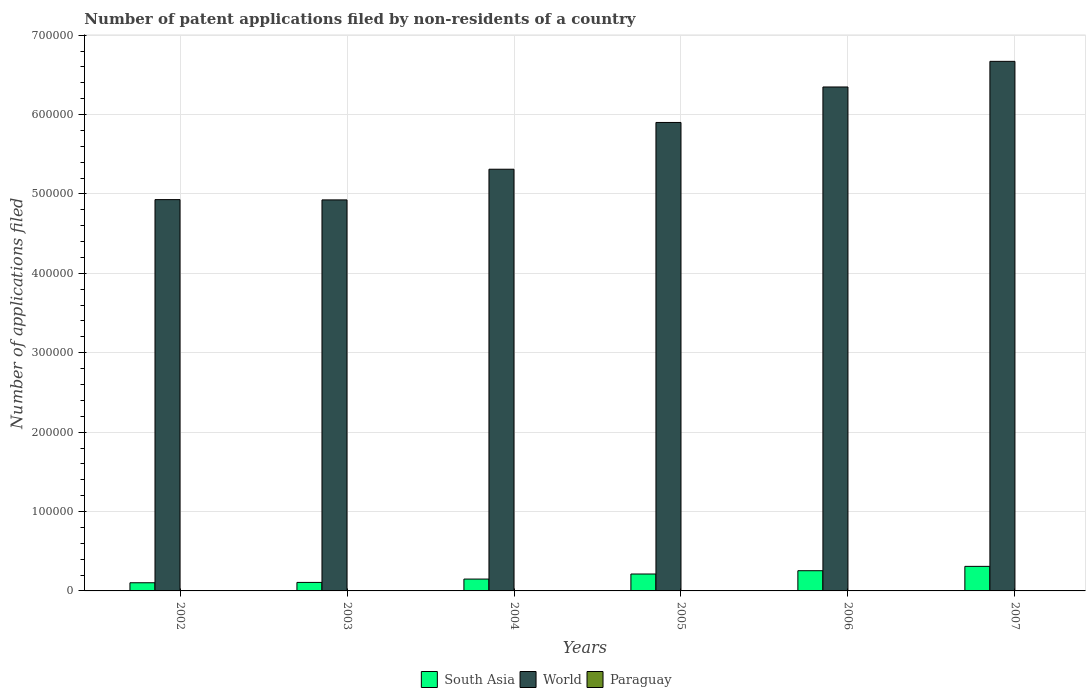How many different coloured bars are there?
Keep it short and to the point. 3. Are the number of bars per tick equal to the number of legend labels?
Offer a very short reply. Yes. How many bars are there on the 3rd tick from the right?
Offer a terse response. 3. What is the number of applications filed in Paraguay in 2002?
Offer a terse response. 171. Across all years, what is the maximum number of applications filed in Paraguay?
Ensure brevity in your answer.  364. Across all years, what is the minimum number of applications filed in Paraguay?
Make the answer very short. 171. What is the total number of applications filed in Paraguay in the graph?
Give a very brief answer. 1431. What is the difference between the number of applications filed in World in 2002 and that in 2005?
Provide a short and direct response. -9.72e+04. What is the difference between the number of applications filed in World in 2007 and the number of applications filed in Paraguay in 2005?
Provide a succinct answer. 6.67e+05. What is the average number of applications filed in South Asia per year?
Your answer should be compact. 1.89e+04. In the year 2005, what is the difference between the number of applications filed in Paraguay and number of applications filed in World?
Make the answer very short. -5.90e+05. In how many years, is the number of applications filed in Paraguay greater than 620000?
Your answer should be compact. 0. What is the ratio of the number of applications filed in South Asia in 2005 to that in 2007?
Keep it short and to the point. 0.69. What is the difference between the highest and the lowest number of applications filed in South Asia?
Offer a very short reply. 2.06e+04. In how many years, is the number of applications filed in World greater than the average number of applications filed in World taken over all years?
Provide a short and direct response. 3. What does the 3rd bar from the left in 2007 represents?
Provide a short and direct response. Paraguay. How many bars are there?
Your answer should be very brief. 18. How many legend labels are there?
Your response must be concise. 3. What is the title of the graph?
Provide a short and direct response. Number of patent applications filed by non-residents of a country. What is the label or title of the Y-axis?
Make the answer very short. Number of applications filed. What is the Number of applications filed of South Asia in 2002?
Your answer should be very brief. 1.03e+04. What is the Number of applications filed of World in 2002?
Provide a short and direct response. 4.93e+05. What is the Number of applications filed in Paraguay in 2002?
Provide a short and direct response. 171. What is the Number of applications filed of South Asia in 2003?
Provide a succinct answer. 1.07e+04. What is the Number of applications filed in World in 2003?
Offer a terse response. 4.93e+05. What is the Number of applications filed of Paraguay in 2003?
Your response must be concise. 173. What is the Number of applications filed of South Asia in 2004?
Your response must be concise. 1.49e+04. What is the Number of applications filed in World in 2004?
Your answer should be compact. 5.31e+05. What is the Number of applications filed of Paraguay in 2004?
Make the answer very short. 187. What is the Number of applications filed in South Asia in 2005?
Make the answer very short. 2.13e+04. What is the Number of applications filed in World in 2005?
Ensure brevity in your answer.  5.90e+05. What is the Number of applications filed in Paraguay in 2005?
Your response must be concise. 241. What is the Number of applications filed in South Asia in 2006?
Make the answer very short. 2.54e+04. What is the Number of applications filed in World in 2006?
Your response must be concise. 6.35e+05. What is the Number of applications filed in Paraguay in 2006?
Provide a succinct answer. 364. What is the Number of applications filed of South Asia in 2007?
Your response must be concise. 3.09e+04. What is the Number of applications filed of World in 2007?
Ensure brevity in your answer.  6.67e+05. What is the Number of applications filed of Paraguay in 2007?
Offer a very short reply. 295. Across all years, what is the maximum Number of applications filed in South Asia?
Offer a very short reply. 3.09e+04. Across all years, what is the maximum Number of applications filed of World?
Ensure brevity in your answer.  6.67e+05. Across all years, what is the maximum Number of applications filed of Paraguay?
Keep it short and to the point. 364. Across all years, what is the minimum Number of applications filed in South Asia?
Ensure brevity in your answer.  1.03e+04. Across all years, what is the minimum Number of applications filed in World?
Offer a terse response. 4.93e+05. Across all years, what is the minimum Number of applications filed in Paraguay?
Your answer should be very brief. 171. What is the total Number of applications filed of South Asia in the graph?
Your answer should be very brief. 1.14e+05. What is the total Number of applications filed in World in the graph?
Provide a short and direct response. 3.41e+06. What is the total Number of applications filed of Paraguay in the graph?
Make the answer very short. 1431. What is the difference between the Number of applications filed of South Asia in 2002 and that in 2003?
Ensure brevity in your answer.  -430. What is the difference between the Number of applications filed of World in 2002 and that in 2003?
Give a very brief answer. 348. What is the difference between the Number of applications filed of Paraguay in 2002 and that in 2003?
Provide a succinct answer. -2. What is the difference between the Number of applications filed of South Asia in 2002 and that in 2004?
Offer a very short reply. -4646. What is the difference between the Number of applications filed in World in 2002 and that in 2004?
Offer a very short reply. -3.83e+04. What is the difference between the Number of applications filed of South Asia in 2002 and that in 2005?
Your answer should be compact. -1.10e+04. What is the difference between the Number of applications filed in World in 2002 and that in 2005?
Your answer should be very brief. -9.72e+04. What is the difference between the Number of applications filed in Paraguay in 2002 and that in 2005?
Ensure brevity in your answer.  -70. What is the difference between the Number of applications filed of South Asia in 2002 and that in 2006?
Offer a very short reply. -1.52e+04. What is the difference between the Number of applications filed in World in 2002 and that in 2006?
Ensure brevity in your answer.  -1.42e+05. What is the difference between the Number of applications filed in Paraguay in 2002 and that in 2006?
Your answer should be very brief. -193. What is the difference between the Number of applications filed in South Asia in 2002 and that in 2007?
Offer a very short reply. -2.06e+04. What is the difference between the Number of applications filed of World in 2002 and that in 2007?
Your response must be concise. -1.74e+05. What is the difference between the Number of applications filed of Paraguay in 2002 and that in 2007?
Your response must be concise. -124. What is the difference between the Number of applications filed in South Asia in 2003 and that in 2004?
Your answer should be very brief. -4216. What is the difference between the Number of applications filed in World in 2003 and that in 2004?
Ensure brevity in your answer.  -3.86e+04. What is the difference between the Number of applications filed in South Asia in 2003 and that in 2005?
Your answer should be compact. -1.06e+04. What is the difference between the Number of applications filed in World in 2003 and that in 2005?
Your answer should be very brief. -9.75e+04. What is the difference between the Number of applications filed of Paraguay in 2003 and that in 2005?
Your answer should be very brief. -68. What is the difference between the Number of applications filed in South Asia in 2003 and that in 2006?
Keep it short and to the point. -1.47e+04. What is the difference between the Number of applications filed in World in 2003 and that in 2006?
Ensure brevity in your answer.  -1.42e+05. What is the difference between the Number of applications filed in Paraguay in 2003 and that in 2006?
Give a very brief answer. -191. What is the difference between the Number of applications filed in South Asia in 2003 and that in 2007?
Give a very brief answer. -2.02e+04. What is the difference between the Number of applications filed of World in 2003 and that in 2007?
Offer a terse response. -1.75e+05. What is the difference between the Number of applications filed in Paraguay in 2003 and that in 2007?
Provide a succinct answer. -122. What is the difference between the Number of applications filed in South Asia in 2004 and that in 2005?
Offer a very short reply. -6384. What is the difference between the Number of applications filed of World in 2004 and that in 2005?
Your response must be concise. -5.89e+04. What is the difference between the Number of applications filed in Paraguay in 2004 and that in 2005?
Provide a succinct answer. -54. What is the difference between the Number of applications filed of South Asia in 2004 and that in 2006?
Your answer should be very brief. -1.05e+04. What is the difference between the Number of applications filed in World in 2004 and that in 2006?
Your response must be concise. -1.04e+05. What is the difference between the Number of applications filed of Paraguay in 2004 and that in 2006?
Offer a terse response. -177. What is the difference between the Number of applications filed of South Asia in 2004 and that in 2007?
Provide a short and direct response. -1.60e+04. What is the difference between the Number of applications filed in World in 2004 and that in 2007?
Your answer should be very brief. -1.36e+05. What is the difference between the Number of applications filed in Paraguay in 2004 and that in 2007?
Your answer should be compact. -108. What is the difference between the Number of applications filed in South Asia in 2005 and that in 2006?
Your response must be concise. -4140. What is the difference between the Number of applications filed of World in 2005 and that in 2006?
Keep it short and to the point. -4.47e+04. What is the difference between the Number of applications filed of Paraguay in 2005 and that in 2006?
Offer a very short reply. -123. What is the difference between the Number of applications filed in South Asia in 2005 and that in 2007?
Provide a succinct answer. -9613. What is the difference between the Number of applications filed in World in 2005 and that in 2007?
Provide a succinct answer. -7.70e+04. What is the difference between the Number of applications filed in Paraguay in 2005 and that in 2007?
Your answer should be very brief. -54. What is the difference between the Number of applications filed of South Asia in 2006 and that in 2007?
Make the answer very short. -5473. What is the difference between the Number of applications filed of World in 2006 and that in 2007?
Your answer should be very brief. -3.23e+04. What is the difference between the Number of applications filed of Paraguay in 2006 and that in 2007?
Your response must be concise. 69. What is the difference between the Number of applications filed of South Asia in 2002 and the Number of applications filed of World in 2003?
Your answer should be compact. -4.82e+05. What is the difference between the Number of applications filed of South Asia in 2002 and the Number of applications filed of Paraguay in 2003?
Provide a succinct answer. 1.01e+04. What is the difference between the Number of applications filed in World in 2002 and the Number of applications filed in Paraguay in 2003?
Your response must be concise. 4.93e+05. What is the difference between the Number of applications filed in South Asia in 2002 and the Number of applications filed in World in 2004?
Your answer should be compact. -5.21e+05. What is the difference between the Number of applications filed of South Asia in 2002 and the Number of applications filed of Paraguay in 2004?
Offer a terse response. 1.01e+04. What is the difference between the Number of applications filed of World in 2002 and the Number of applications filed of Paraguay in 2004?
Give a very brief answer. 4.93e+05. What is the difference between the Number of applications filed in South Asia in 2002 and the Number of applications filed in World in 2005?
Offer a terse response. -5.80e+05. What is the difference between the Number of applications filed in South Asia in 2002 and the Number of applications filed in Paraguay in 2005?
Your response must be concise. 1.00e+04. What is the difference between the Number of applications filed in World in 2002 and the Number of applications filed in Paraguay in 2005?
Provide a succinct answer. 4.93e+05. What is the difference between the Number of applications filed in South Asia in 2002 and the Number of applications filed in World in 2006?
Offer a very short reply. -6.24e+05. What is the difference between the Number of applications filed of South Asia in 2002 and the Number of applications filed of Paraguay in 2006?
Provide a succinct answer. 9913. What is the difference between the Number of applications filed in World in 2002 and the Number of applications filed in Paraguay in 2006?
Your answer should be very brief. 4.93e+05. What is the difference between the Number of applications filed of South Asia in 2002 and the Number of applications filed of World in 2007?
Offer a terse response. -6.57e+05. What is the difference between the Number of applications filed in South Asia in 2002 and the Number of applications filed in Paraguay in 2007?
Your response must be concise. 9982. What is the difference between the Number of applications filed in World in 2002 and the Number of applications filed in Paraguay in 2007?
Make the answer very short. 4.93e+05. What is the difference between the Number of applications filed in South Asia in 2003 and the Number of applications filed in World in 2004?
Keep it short and to the point. -5.20e+05. What is the difference between the Number of applications filed of South Asia in 2003 and the Number of applications filed of Paraguay in 2004?
Offer a very short reply. 1.05e+04. What is the difference between the Number of applications filed of World in 2003 and the Number of applications filed of Paraguay in 2004?
Your response must be concise. 4.92e+05. What is the difference between the Number of applications filed of South Asia in 2003 and the Number of applications filed of World in 2005?
Provide a short and direct response. -5.79e+05. What is the difference between the Number of applications filed in South Asia in 2003 and the Number of applications filed in Paraguay in 2005?
Your response must be concise. 1.05e+04. What is the difference between the Number of applications filed of World in 2003 and the Number of applications filed of Paraguay in 2005?
Your response must be concise. 4.92e+05. What is the difference between the Number of applications filed of South Asia in 2003 and the Number of applications filed of World in 2006?
Ensure brevity in your answer.  -6.24e+05. What is the difference between the Number of applications filed of South Asia in 2003 and the Number of applications filed of Paraguay in 2006?
Provide a short and direct response. 1.03e+04. What is the difference between the Number of applications filed of World in 2003 and the Number of applications filed of Paraguay in 2006?
Offer a very short reply. 4.92e+05. What is the difference between the Number of applications filed in South Asia in 2003 and the Number of applications filed in World in 2007?
Provide a short and direct response. -6.56e+05. What is the difference between the Number of applications filed in South Asia in 2003 and the Number of applications filed in Paraguay in 2007?
Give a very brief answer. 1.04e+04. What is the difference between the Number of applications filed in World in 2003 and the Number of applications filed in Paraguay in 2007?
Provide a short and direct response. 4.92e+05. What is the difference between the Number of applications filed in South Asia in 2004 and the Number of applications filed in World in 2005?
Offer a terse response. -5.75e+05. What is the difference between the Number of applications filed of South Asia in 2004 and the Number of applications filed of Paraguay in 2005?
Offer a very short reply. 1.47e+04. What is the difference between the Number of applications filed of World in 2004 and the Number of applications filed of Paraguay in 2005?
Your response must be concise. 5.31e+05. What is the difference between the Number of applications filed in South Asia in 2004 and the Number of applications filed in World in 2006?
Give a very brief answer. -6.20e+05. What is the difference between the Number of applications filed of South Asia in 2004 and the Number of applications filed of Paraguay in 2006?
Keep it short and to the point. 1.46e+04. What is the difference between the Number of applications filed in World in 2004 and the Number of applications filed in Paraguay in 2006?
Ensure brevity in your answer.  5.31e+05. What is the difference between the Number of applications filed in South Asia in 2004 and the Number of applications filed in World in 2007?
Make the answer very short. -6.52e+05. What is the difference between the Number of applications filed of South Asia in 2004 and the Number of applications filed of Paraguay in 2007?
Your answer should be very brief. 1.46e+04. What is the difference between the Number of applications filed of World in 2004 and the Number of applications filed of Paraguay in 2007?
Make the answer very short. 5.31e+05. What is the difference between the Number of applications filed in South Asia in 2005 and the Number of applications filed in World in 2006?
Keep it short and to the point. -6.13e+05. What is the difference between the Number of applications filed of South Asia in 2005 and the Number of applications filed of Paraguay in 2006?
Make the answer very short. 2.09e+04. What is the difference between the Number of applications filed in World in 2005 and the Number of applications filed in Paraguay in 2006?
Make the answer very short. 5.90e+05. What is the difference between the Number of applications filed in South Asia in 2005 and the Number of applications filed in World in 2007?
Your answer should be very brief. -6.46e+05. What is the difference between the Number of applications filed of South Asia in 2005 and the Number of applications filed of Paraguay in 2007?
Your answer should be compact. 2.10e+04. What is the difference between the Number of applications filed of World in 2005 and the Number of applications filed of Paraguay in 2007?
Your answer should be very brief. 5.90e+05. What is the difference between the Number of applications filed in South Asia in 2006 and the Number of applications filed in World in 2007?
Offer a terse response. -6.42e+05. What is the difference between the Number of applications filed of South Asia in 2006 and the Number of applications filed of Paraguay in 2007?
Offer a terse response. 2.52e+04. What is the difference between the Number of applications filed of World in 2006 and the Number of applications filed of Paraguay in 2007?
Offer a terse response. 6.34e+05. What is the average Number of applications filed in South Asia per year?
Make the answer very short. 1.89e+04. What is the average Number of applications filed of World per year?
Ensure brevity in your answer.  5.68e+05. What is the average Number of applications filed of Paraguay per year?
Make the answer very short. 238.5. In the year 2002, what is the difference between the Number of applications filed of South Asia and Number of applications filed of World?
Provide a short and direct response. -4.83e+05. In the year 2002, what is the difference between the Number of applications filed in South Asia and Number of applications filed in Paraguay?
Offer a very short reply. 1.01e+04. In the year 2002, what is the difference between the Number of applications filed in World and Number of applications filed in Paraguay?
Provide a short and direct response. 4.93e+05. In the year 2003, what is the difference between the Number of applications filed of South Asia and Number of applications filed of World?
Offer a very short reply. -4.82e+05. In the year 2003, what is the difference between the Number of applications filed in South Asia and Number of applications filed in Paraguay?
Your response must be concise. 1.05e+04. In the year 2003, what is the difference between the Number of applications filed of World and Number of applications filed of Paraguay?
Ensure brevity in your answer.  4.92e+05. In the year 2004, what is the difference between the Number of applications filed in South Asia and Number of applications filed in World?
Give a very brief answer. -5.16e+05. In the year 2004, what is the difference between the Number of applications filed of South Asia and Number of applications filed of Paraguay?
Provide a short and direct response. 1.47e+04. In the year 2004, what is the difference between the Number of applications filed of World and Number of applications filed of Paraguay?
Keep it short and to the point. 5.31e+05. In the year 2005, what is the difference between the Number of applications filed of South Asia and Number of applications filed of World?
Keep it short and to the point. -5.69e+05. In the year 2005, what is the difference between the Number of applications filed in South Asia and Number of applications filed in Paraguay?
Provide a short and direct response. 2.11e+04. In the year 2005, what is the difference between the Number of applications filed of World and Number of applications filed of Paraguay?
Your response must be concise. 5.90e+05. In the year 2006, what is the difference between the Number of applications filed in South Asia and Number of applications filed in World?
Your response must be concise. -6.09e+05. In the year 2006, what is the difference between the Number of applications filed of South Asia and Number of applications filed of Paraguay?
Ensure brevity in your answer.  2.51e+04. In the year 2006, what is the difference between the Number of applications filed in World and Number of applications filed in Paraguay?
Your answer should be compact. 6.34e+05. In the year 2007, what is the difference between the Number of applications filed in South Asia and Number of applications filed in World?
Ensure brevity in your answer.  -6.36e+05. In the year 2007, what is the difference between the Number of applications filed of South Asia and Number of applications filed of Paraguay?
Your answer should be very brief. 3.06e+04. In the year 2007, what is the difference between the Number of applications filed of World and Number of applications filed of Paraguay?
Give a very brief answer. 6.67e+05. What is the ratio of the Number of applications filed in South Asia in 2002 to that in 2003?
Provide a short and direct response. 0.96. What is the ratio of the Number of applications filed of World in 2002 to that in 2003?
Make the answer very short. 1. What is the ratio of the Number of applications filed in Paraguay in 2002 to that in 2003?
Your answer should be compact. 0.99. What is the ratio of the Number of applications filed of South Asia in 2002 to that in 2004?
Keep it short and to the point. 0.69. What is the ratio of the Number of applications filed of World in 2002 to that in 2004?
Your answer should be very brief. 0.93. What is the ratio of the Number of applications filed of Paraguay in 2002 to that in 2004?
Your response must be concise. 0.91. What is the ratio of the Number of applications filed in South Asia in 2002 to that in 2005?
Your answer should be very brief. 0.48. What is the ratio of the Number of applications filed of World in 2002 to that in 2005?
Give a very brief answer. 0.84. What is the ratio of the Number of applications filed of Paraguay in 2002 to that in 2005?
Ensure brevity in your answer.  0.71. What is the ratio of the Number of applications filed of South Asia in 2002 to that in 2006?
Offer a very short reply. 0.4. What is the ratio of the Number of applications filed in World in 2002 to that in 2006?
Provide a short and direct response. 0.78. What is the ratio of the Number of applications filed in Paraguay in 2002 to that in 2006?
Provide a short and direct response. 0.47. What is the ratio of the Number of applications filed in South Asia in 2002 to that in 2007?
Provide a short and direct response. 0.33. What is the ratio of the Number of applications filed of World in 2002 to that in 2007?
Your response must be concise. 0.74. What is the ratio of the Number of applications filed of Paraguay in 2002 to that in 2007?
Give a very brief answer. 0.58. What is the ratio of the Number of applications filed of South Asia in 2003 to that in 2004?
Offer a terse response. 0.72. What is the ratio of the Number of applications filed in World in 2003 to that in 2004?
Ensure brevity in your answer.  0.93. What is the ratio of the Number of applications filed of Paraguay in 2003 to that in 2004?
Offer a terse response. 0.93. What is the ratio of the Number of applications filed of South Asia in 2003 to that in 2005?
Provide a short and direct response. 0.5. What is the ratio of the Number of applications filed in World in 2003 to that in 2005?
Your answer should be very brief. 0.83. What is the ratio of the Number of applications filed in Paraguay in 2003 to that in 2005?
Make the answer very short. 0.72. What is the ratio of the Number of applications filed of South Asia in 2003 to that in 2006?
Provide a succinct answer. 0.42. What is the ratio of the Number of applications filed in World in 2003 to that in 2006?
Make the answer very short. 0.78. What is the ratio of the Number of applications filed of Paraguay in 2003 to that in 2006?
Offer a very short reply. 0.48. What is the ratio of the Number of applications filed in South Asia in 2003 to that in 2007?
Provide a short and direct response. 0.35. What is the ratio of the Number of applications filed of World in 2003 to that in 2007?
Offer a terse response. 0.74. What is the ratio of the Number of applications filed of Paraguay in 2003 to that in 2007?
Make the answer very short. 0.59. What is the ratio of the Number of applications filed of South Asia in 2004 to that in 2005?
Provide a succinct answer. 0.7. What is the ratio of the Number of applications filed of World in 2004 to that in 2005?
Ensure brevity in your answer.  0.9. What is the ratio of the Number of applications filed of Paraguay in 2004 to that in 2005?
Your response must be concise. 0.78. What is the ratio of the Number of applications filed of South Asia in 2004 to that in 2006?
Make the answer very short. 0.59. What is the ratio of the Number of applications filed of World in 2004 to that in 2006?
Make the answer very short. 0.84. What is the ratio of the Number of applications filed of Paraguay in 2004 to that in 2006?
Make the answer very short. 0.51. What is the ratio of the Number of applications filed in South Asia in 2004 to that in 2007?
Give a very brief answer. 0.48. What is the ratio of the Number of applications filed in World in 2004 to that in 2007?
Your answer should be very brief. 0.8. What is the ratio of the Number of applications filed in Paraguay in 2004 to that in 2007?
Provide a succinct answer. 0.63. What is the ratio of the Number of applications filed of South Asia in 2005 to that in 2006?
Keep it short and to the point. 0.84. What is the ratio of the Number of applications filed of World in 2005 to that in 2006?
Ensure brevity in your answer.  0.93. What is the ratio of the Number of applications filed in Paraguay in 2005 to that in 2006?
Offer a terse response. 0.66. What is the ratio of the Number of applications filed in South Asia in 2005 to that in 2007?
Offer a terse response. 0.69. What is the ratio of the Number of applications filed of World in 2005 to that in 2007?
Your answer should be very brief. 0.88. What is the ratio of the Number of applications filed in Paraguay in 2005 to that in 2007?
Ensure brevity in your answer.  0.82. What is the ratio of the Number of applications filed in South Asia in 2006 to that in 2007?
Offer a terse response. 0.82. What is the ratio of the Number of applications filed of World in 2006 to that in 2007?
Provide a succinct answer. 0.95. What is the ratio of the Number of applications filed of Paraguay in 2006 to that in 2007?
Keep it short and to the point. 1.23. What is the difference between the highest and the second highest Number of applications filed in South Asia?
Keep it short and to the point. 5473. What is the difference between the highest and the second highest Number of applications filed of World?
Provide a short and direct response. 3.23e+04. What is the difference between the highest and the second highest Number of applications filed of Paraguay?
Your response must be concise. 69. What is the difference between the highest and the lowest Number of applications filed of South Asia?
Your answer should be compact. 2.06e+04. What is the difference between the highest and the lowest Number of applications filed of World?
Your response must be concise. 1.75e+05. What is the difference between the highest and the lowest Number of applications filed in Paraguay?
Give a very brief answer. 193. 